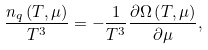Convert formula to latex. <formula><loc_0><loc_0><loc_500><loc_500>\frac { n _ { q } \left ( T , \mu \right ) } { T ^ { 3 } } = - \frac { 1 } { T ^ { 3 } } \frac { \partial \Omega \left ( T , \mu \right ) } { \partial \mu } ,</formula> 